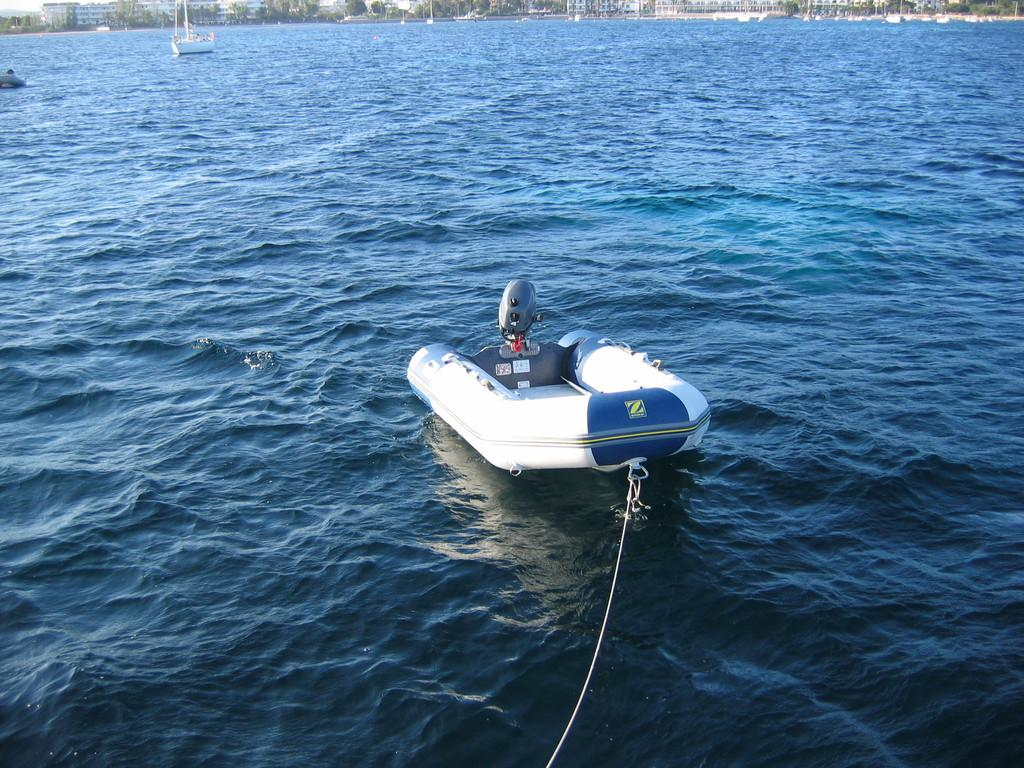<image>
Summarize the visual content of the image. the letter Z is on the back of a boat 